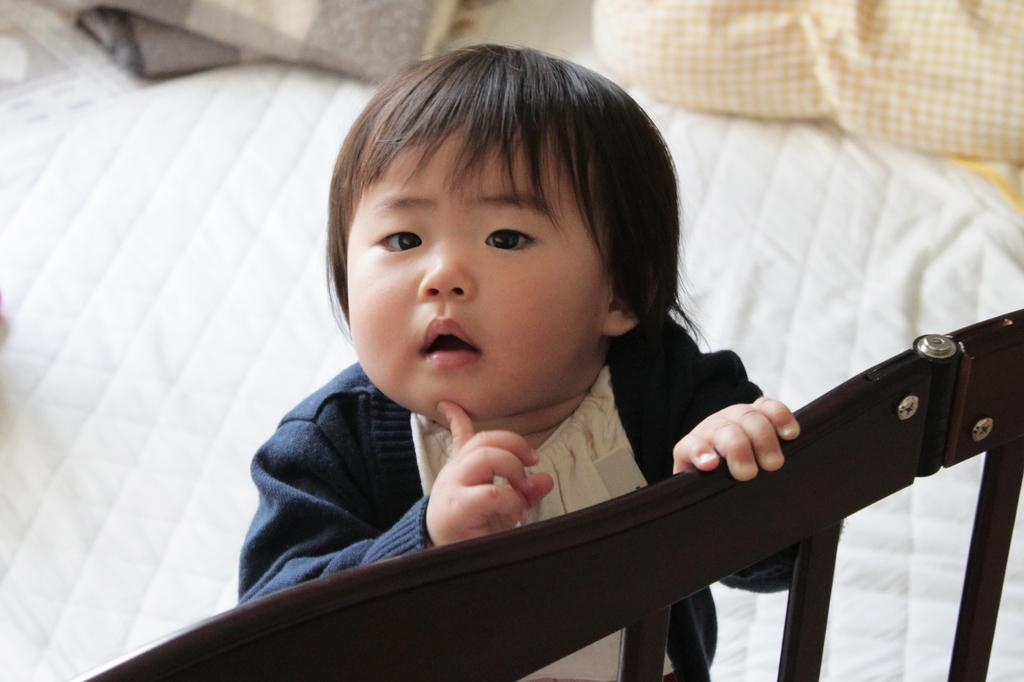What is the kid doing in the image? The kid is standing on the bed and holding one of the bed's railings. What is the kid's body language in the image? The kid has a hand under his chin. What is the kid wearing in the image? The kid is wearing a blue jacket. What is behind the kid in the image? There is a pillow behind the kid. What can be seen on the bed in the image? Bed sheets are visible in the image. What type of force is being exerted by the jellyfish in the image? There are no jellyfish present in the image, so it is not possible to determine the type of force being exerted. 